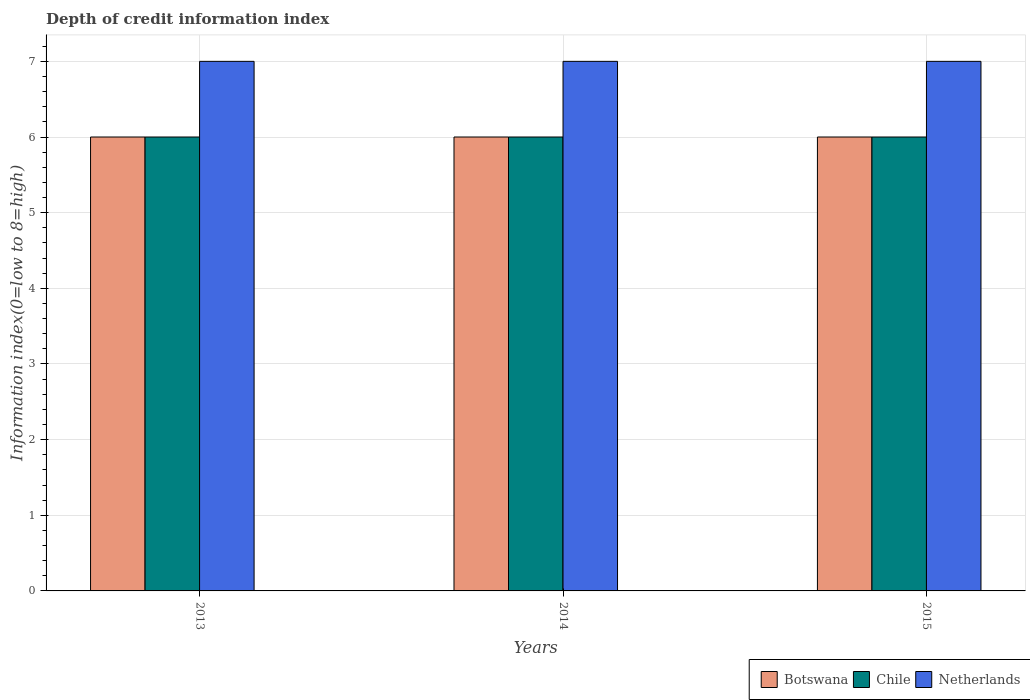How many different coloured bars are there?
Make the answer very short. 3. How many groups of bars are there?
Provide a succinct answer. 3. Are the number of bars per tick equal to the number of legend labels?
Your answer should be very brief. Yes. Are the number of bars on each tick of the X-axis equal?
Provide a succinct answer. Yes. How many bars are there on the 2nd tick from the left?
Offer a terse response. 3. How many bars are there on the 3rd tick from the right?
Your answer should be compact. 3. In how many cases, is the number of bars for a given year not equal to the number of legend labels?
Provide a succinct answer. 0. What is the information index in Netherlands in 2015?
Offer a terse response. 7. Across all years, what is the maximum information index in Chile?
Your answer should be very brief. 6. Across all years, what is the minimum information index in Netherlands?
Provide a short and direct response. 7. In which year was the information index in Botswana maximum?
Provide a succinct answer. 2013. What is the total information index in Netherlands in the graph?
Provide a succinct answer. 21. What is the difference between the information index in Botswana in 2014 and that in 2015?
Offer a very short reply. 0. What is the difference between the information index in Netherlands in 2015 and the information index in Botswana in 2013?
Provide a short and direct response. 1. What is the average information index in Netherlands per year?
Your answer should be very brief. 7. In the year 2015, what is the difference between the information index in Netherlands and information index in Botswana?
Your response must be concise. 1. Is the difference between the information index in Netherlands in 2014 and 2015 greater than the difference between the information index in Botswana in 2014 and 2015?
Your answer should be very brief. No. In how many years, is the information index in Botswana greater than the average information index in Botswana taken over all years?
Your answer should be very brief. 0. What does the 3rd bar from the left in 2015 represents?
Your answer should be very brief. Netherlands. What does the 3rd bar from the right in 2015 represents?
Make the answer very short. Botswana. Are all the bars in the graph horizontal?
Offer a terse response. No. How many years are there in the graph?
Offer a terse response. 3. What is the difference between two consecutive major ticks on the Y-axis?
Offer a terse response. 1. Does the graph contain any zero values?
Your answer should be very brief. No. Does the graph contain grids?
Provide a short and direct response. Yes. How many legend labels are there?
Make the answer very short. 3. How are the legend labels stacked?
Ensure brevity in your answer.  Horizontal. What is the title of the graph?
Your response must be concise. Depth of credit information index. Does "Arab World" appear as one of the legend labels in the graph?
Offer a terse response. No. What is the label or title of the Y-axis?
Make the answer very short. Information index(0=low to 8=high). What is the Information index(0=low to 8=high) of Chile in 2013?
Keep it short and to the point. 6. What is the Information index(0=low to 8=high) of Netherlands in 2013?
Offer a terse response. 7. What is the Information index(0=low to 8=high) in Chile in 2015?
Keep it short and to the point. 6. What is the Information index(0=low to 8=high) in Netherlands in 2015?
Provide a succinct answer. 7. Across all years, what is the maximum Information index(0=low to 8=high) in Botswana?
Your answer should be compact. 6. Across all years, what is the maximum Information index(0=low to 8=high) of Chile?
Provide a succinct answer. 6. Across all years, what is the minimum Information index(0=low to 8=high) of Chile?
Offer a very short reply. 6. Across all years, what is the minimum Information index(0=low to 8=high) in Netherlands?
Give a very brief answer. 7. What is the total Information index(0=low to 8=high) in Botswana in the graph?
Your response must be concise. 18. What is the total Information index(0=low to 8=high) of Chile in the graph?
Your answer should be very brief. 18. What is the total Information index(0=low to 8=high) of Netherlands in the graph?
Your answer should be very brief. 21. What is the difference between the Information index(0=low to 8=high) in Netherlands in 2013 and that in 2014?
Keep it short and to the point. 0. What is the difference between the Information index(0=low to 8=high) of Chile in 2013 and that in 2015?
Your answer should be compact. 0. What is the difference between the Information index(0=low to 8=high) of Botswana in 2014 and that in 2015?
Your answer should be compact. 0. What is the difference between the Information index(0=low to 8=high) in Chile in 2014 and that in 2015?
Provide a succinct answer. 0. What is the difference between the Information index(0=low to 8=high) of Chile in 2013 and the Information index(0=low to 8=high) of Netherlands in 2015?
Your answer should be very brief. -1. What is the difference between the Information index(0=low to 8=high) in Botswana in 2014 and the Information index(0=low to 8=high) in Chile in 2015?
Offer a terse response. 0. What is the average Information index(0=low to 8=high) of Chile per year?
Keep it short and to the point. 6. What is the average Information index(0=low to 8=high) of Netherlands per year?
Give a very brief answer. 7. In the year 2013, what is the difference between the Information index(0=low to 8=high) of Botswana and Information index(0=low to 8=high) of Chile?
Your answer should be compact. 0. In the year 2013, what is the difference between the Information index(0=low to 8=high) in Botswana and Information index(0=low to 8=high) in Netherlands?
Provide a succinct answer. -1. In the year 2014, what is the difference between the Information index(0=low to 8=high) of Botswana and Information index(0=low to 8=high) of Chile?
Ensure brevity in your answer.  0. In the year 2014, what is the difference between the Information index(0=low to 8=high) of Chile and Information index(0=low to 8=high) of Netherlands?
Offer a very short reply. -1. In the year 2015, what is the difference between the Information index(0=low to 8=high) of Botswana and Information index(0=low to 8=high) of Chile?
Keep it short and to the point. 0. In the year 2015, what is the difference between the Information index(0=low to 8=high) of Chile and Information index(0=low to 8=high) of Netherlands?
Make the answer very short. -1. What is the ratio of the Information index(0=low to 8=high) in Chile in 2013 to that in 2015?
Provide a succinct answer. 1. What is the ratio of the Information index(0=low to 8=high) of Chile in 2014 to that in 2015?
Your response must be concise. 1. What is the ratio of the Information index(0=low to 8=high) of Netherlands in 2014 to that in 2015?
Give a very brief answer. 1. 